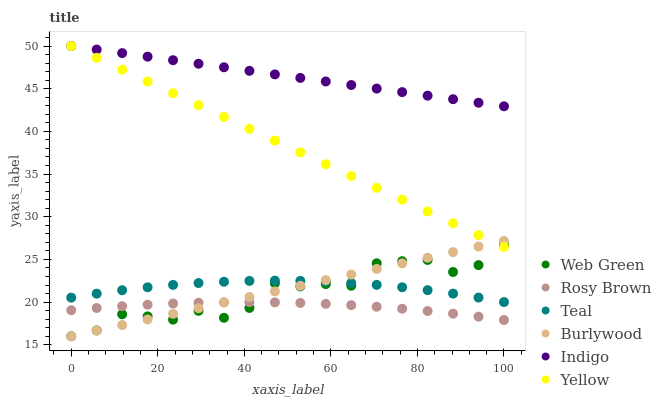Does Rosy Brown have the minimum area under the curve?
Answer yes or no. Yes. Does Indigo have the maximum area under the curve?
Answer yes or no. Yes. Does Burlywood have the minimum area under the curve?
Answer yes or no. No. Does Burlywood have the maximum area under the curve?
Answer yes or no. No. Is Burlywood the smoothest?
Answer yes or no. Yes. Is Web Green the roughest?
Answer yes or no. Yes. Is Rosy Brown the smoothest?
Answer yes or no. No. Is Rosy Brown the roughest?
Answer yes or no. No. Does Burlywood have the lowest value?
Answer yes or no. Yes. Does Rosy Brown have the lowest value?
Answer yes or no. No. Does Yellow have the highest value?
Answer yes or no. Yes. Does Burlywood have the highest value?
Answer yes or no. No. Is Rosy Brown less than Indigo?
Answer yes or no. Yes. Is Yellow greater than Teal?
Answer yes or no. Yes. Does Teal intersect Burlywood?
Answer yes or no. Yes. Is Teal less than Burlywood?
Answer yes or no. No. Is Teal greater than Burlywood?
Answer yes or no. No. Does Rosy Brown intersect Indigo?
Answer yes or no. No. 